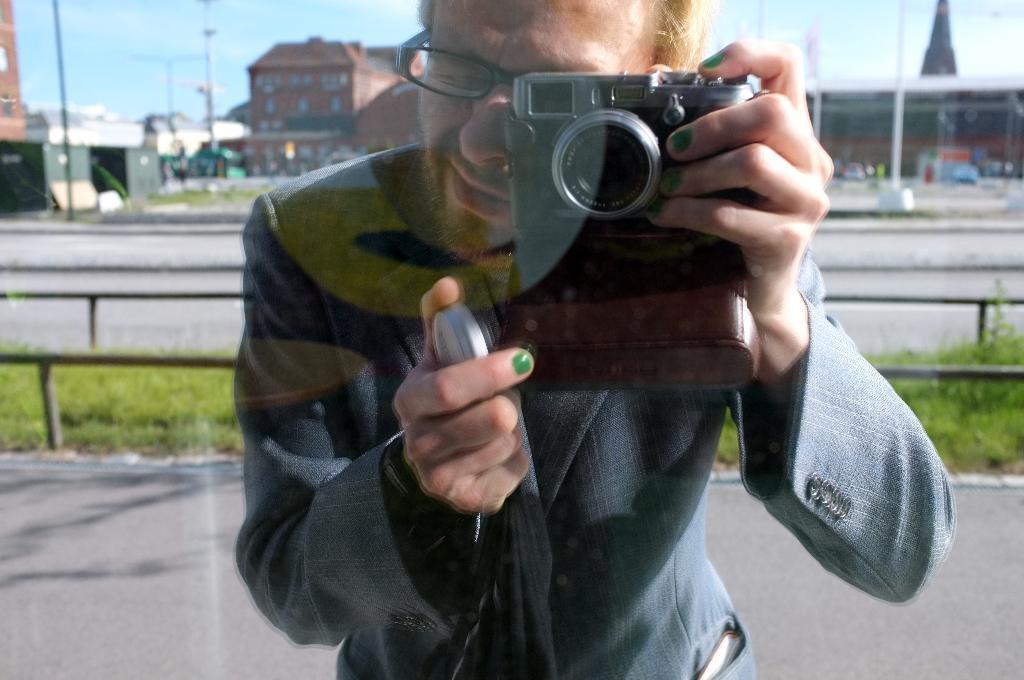Could you give a brief overview of what you see in this image? In the image there is a camera stood holding a camera and on the background there are buildings,road,grass. And over the top there is sky. 